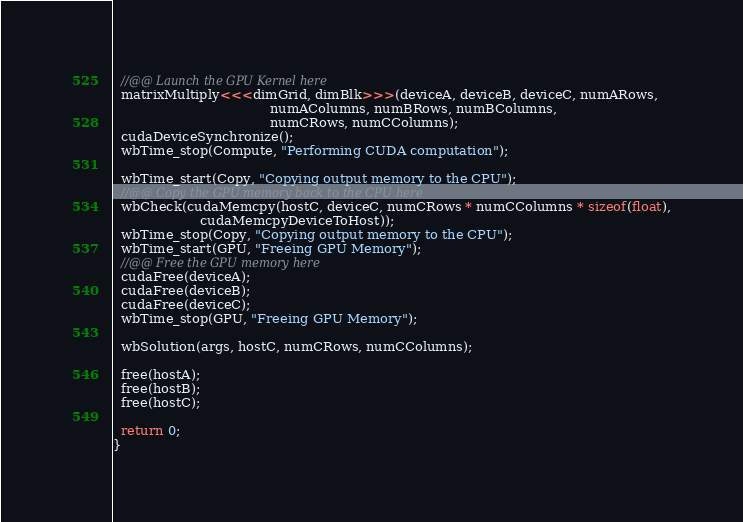Convert code to text. <code><loc_0><loc_0><loc_500><loc_500><_Cuda_>  //@@ Launch the GPU Kernel here
  matrixMultiply<<<dimGrid, dimBlk>>>(deviceA, deviceB, deviceC, numARows,
                                      numAColumns, numBRows, numBColumns,
                                      numCRows, numCColumns);
  cudaDeviceSynchronize();
  wbTime_stop(Compute, "Performing CUDA computation");

  wbTime_start(Copy, "Copying output memory to the CPU");
  //@@ Copy the GPU memory back to the CPU here
  wbCheck(cudaMemcpy(hostC, deviceC, numCRows * numCColumns * sizeof(float),
                     cudaMemcpyDeviceToHost));
  wbTime_stop(Copy, "Copying output memory to the CPU");
  wbTime_start(GPU, "Freeing GPU Memory");
  //@@ Free the GPU memory here
  cudaFree(deviceA);
  cudaFree(deviceB);
  cudaFree(deviceC);
  wbTime_stop(GPU, "Freeing GPU Memory");

  wbSolution(args, hostC, numCRows, numCColumns);

  free(hostA);
  free(hostB);
  free(hostC);

  return 0;
}
</code> 